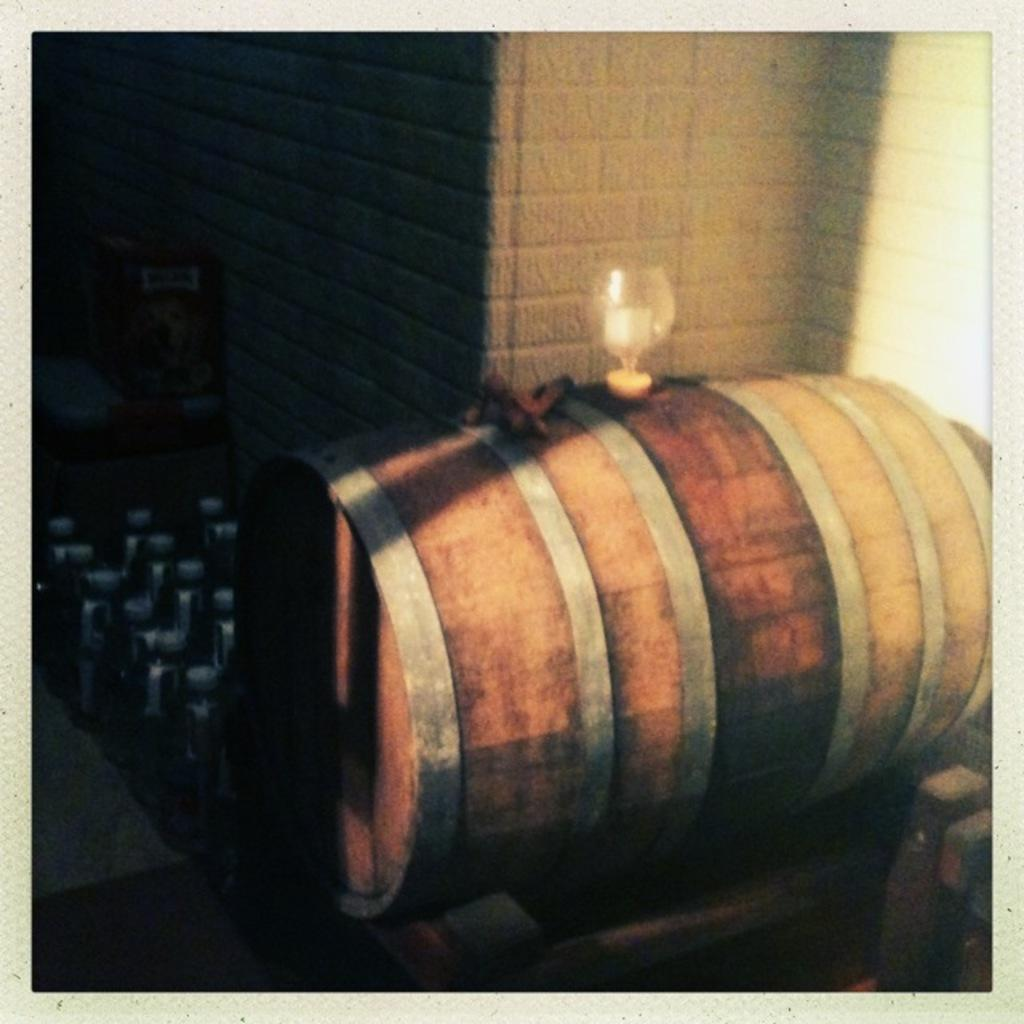What type of material is the object in the image made of? The wooden object in the image is made of wood. What is placed on the wooden object? A glass is placed on the wooden object. Can you describe any other objects visible in the image? There are other objects visible in the image, but their specific details are not mentioned in the provided facts. What can be seen in the background of the image? There is a wall in the background of the image. How many hills can be seen in the image? There are no hills visible in the image; only a wooden object, a glass, and a wall are present. What type of soda is being served in the glass? The provided facts do not mention any soda or drink in the glass, so it cannot be determined from the image. 